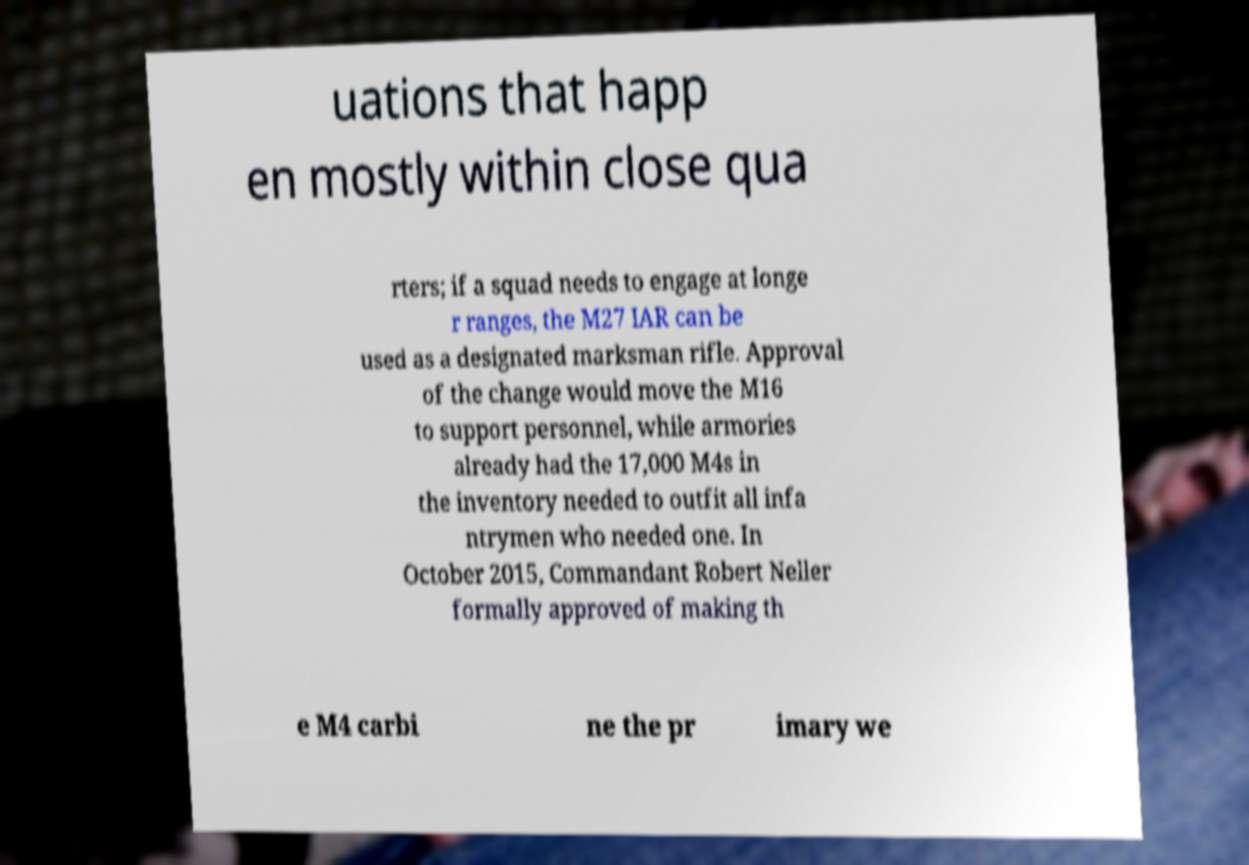Can you read and provide the text displayed in the image?This photo seems to have some interesting text. Can you extract and type it out for me? uations that happ en mostly within close qua rters; if a squad needs to engage at longe r ranges, the M27 IAR can be used as a designated marksman rifle. Approval of the change would move the M16 to support personnel, while armories already had the 17,000 M4s in the inventory needed to outfit all infa ntrymen who needed one. In October 2015, Commandant Robert Neller formally approved of making th e M4 carbi ne the pr imary we 